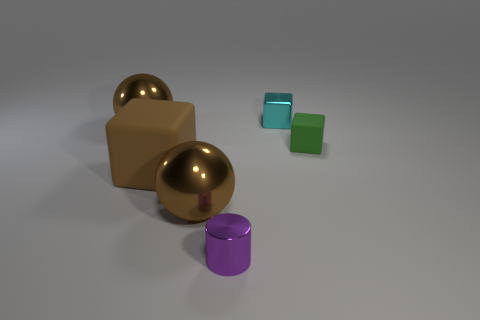Subtract all small blocks. How many blocks are left? 1 Add 4 large matte objects. How many objects exist? 10 Subtract 1 cubes. How many cubes are left? 2 Subtract all cyan cubes. How many cubes are left? 2 Subtract all cylinders. How many objects are left? 5 Subtract all shiny blocks. Subtract all tiny purple things. How many objects are left? 4 Add 3 rubber things. How many rubber things are left? 5 Add 4 green cylinders. How many green cylinders exist? 4 Subtract 0 yellow cylinders. How many objects are left? 6 Subtract all gray cylinders. Subtract all blue spheres. How many cylinders are left? 1 